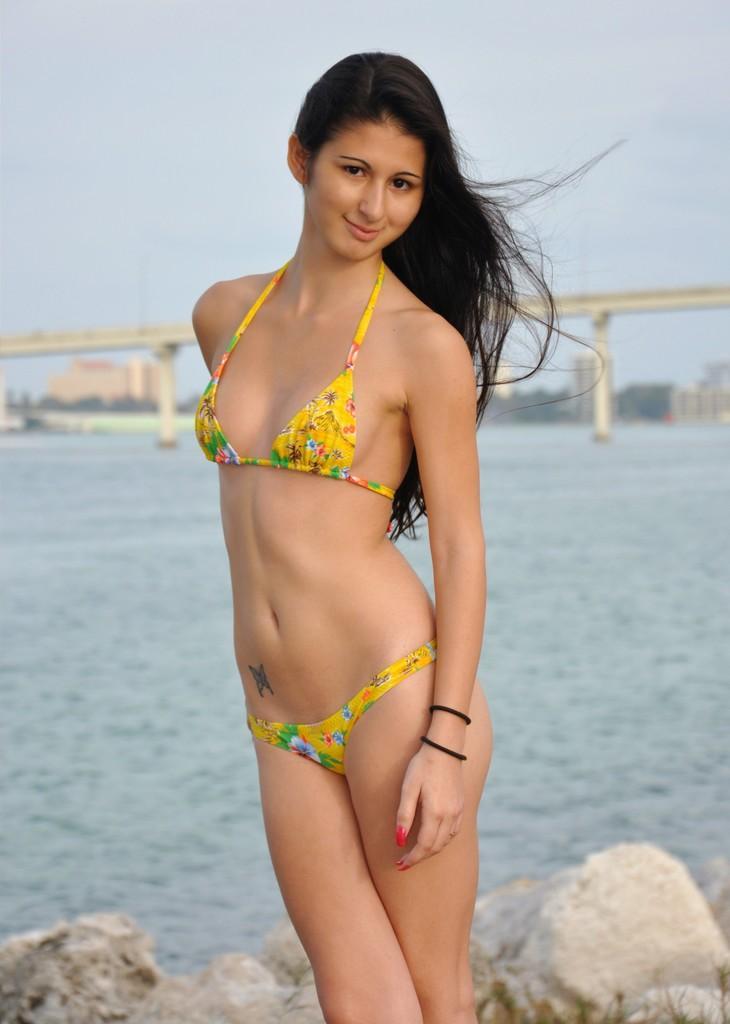Can you describe this image briefly? In this image I can see a beautiful woman in yellow color top and short. She is smiling, behind her, there is water and a bridge. At the top it is the sky. 